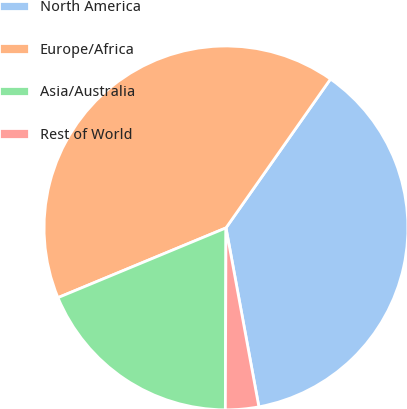<chart> <loc_0><loc_0><loc_500><loc_500><pie_chart><fcel>North America<fcel>Europe/Africa<fcel>Asia/Australia<fcel>Rest of World<nl><fcel>37.36%<fcel>41.0%<fcel>18.68%<fcel>2.95%<nl></chart> 